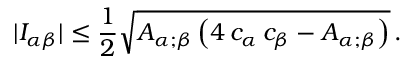Convert formula to latex. <formula><loc_0><loc_0><loc_500><loc_500>| I _ { \alpha \beta } | \leq \frac { 1 } { 2 } \sqrt { A _ { \alpha ; \beta } \left ( 4 \, c _ { \alpha } \, c _ { \beta } - A _ { \alpha ; \beta } \right ) } \, .</formula> 